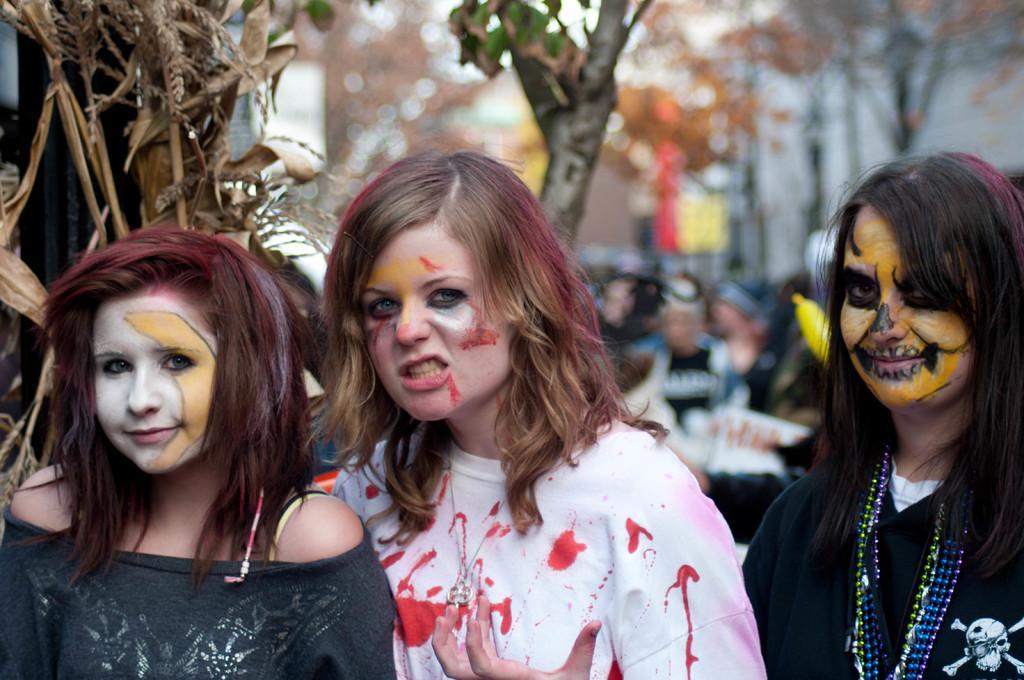How would you summarize this image in a sentence or two? To the left side of the image there is a lady with black dress is standing and on her face there is a mask. And in the middle of the image there is a lady with white t-shirt and red marks on it, on her face there is a painting. To the right corner of the image there is a lady with black dress, chains around her neck, skull symbol on the t-shirt and also there is a painting on her face. In the background there are few trees and also there are few people. 